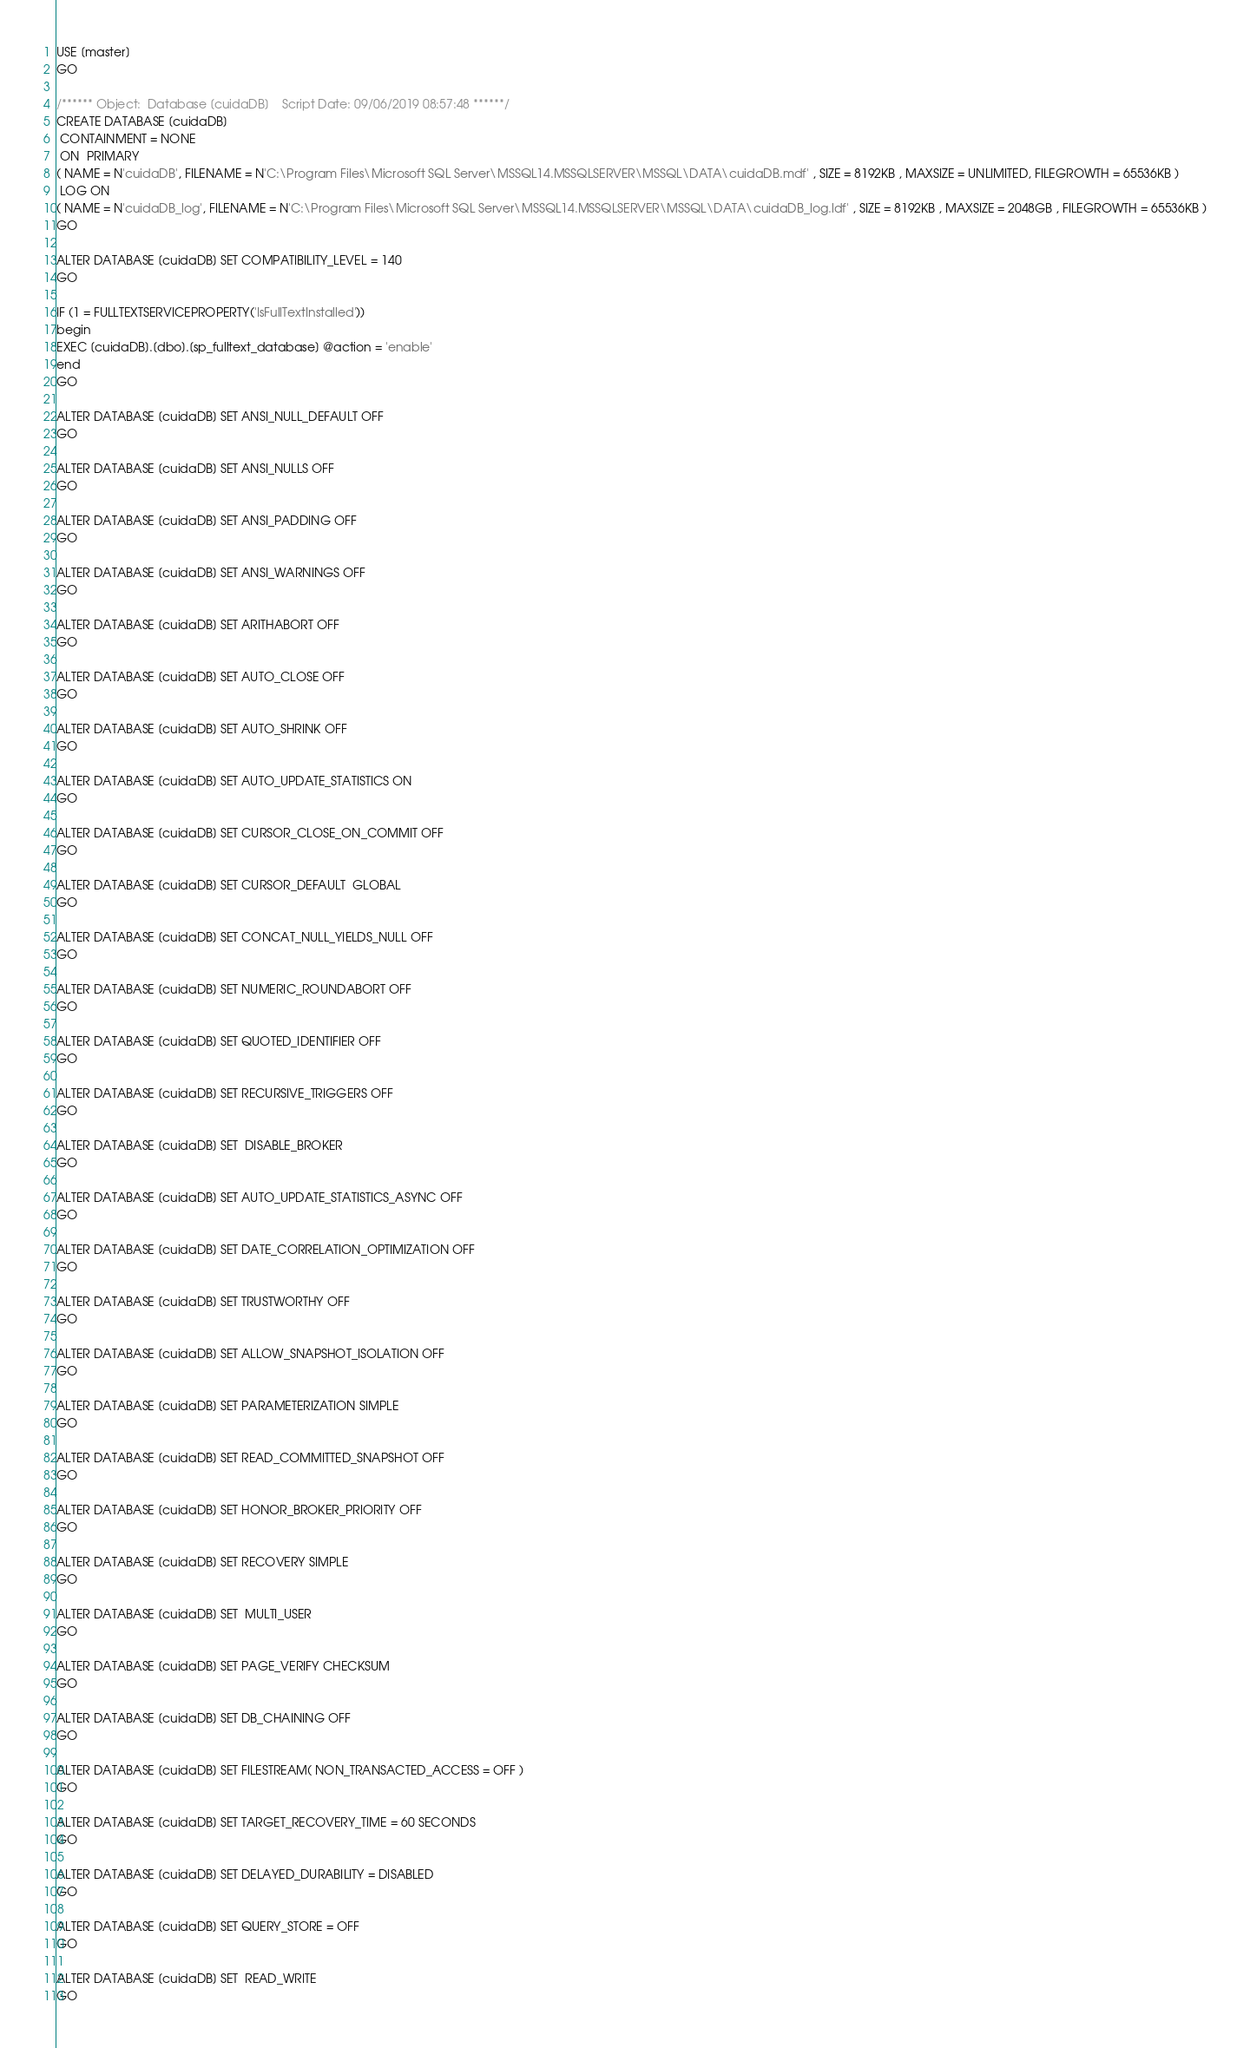Convert code to text. <code><loc_0><loc_0><loc_500><loc_500><_SQL_>USE [master]
GO

/****** Object:  Database [cuidaDB]    Script Date: 09/06/2019 08:57:48 ******/
CREATE DATABASE [cuidaDB]
 CONTAINMENT = NONE
 ON  PRIMARY 
( NAME = N'cuidaDB', FILENAME = N'C:\Program Files\Microsoft SQL Server\MSSQL14.MSSQLSERVER\MSSQL\DATA\cuidaDB.mdf' , SIZE = 8192KB , MAXSIZE = UNLIMITED, FILEGROWTH = 65536KB )
 LOG ON 
( NAME = N'cuidaDB_log', FILENAME = N'C:\Program Files\Microsoft SQL Server\MSSQL14.MSSQLSERVER\MSSQL\DATA\cuidaDB_log.ldf' , SIZE = 8192KB , MAXSIZE = 2048GB , FILEGROWTH = 65536KB )
GO

ALTER DATABASE [cuidaDB] SET COMPATIBILITY_LEVEL = 140
GO

IF (1 = FULLTEXTSERVICEPROPERTY('IsFullTextInstalled'))
begin
EXEC [cuidaDB].[dbo].[sp_fulltext_database] @action = 'enable'
end
GO

ALTER DATABASE [cuidaDB] SET ANSI_NULL_DEFAULT OFF 
GO

ALTER DATABASE [cuidaDB] SET ANSI_NULLS OFF 
GO

ALTER DATABASE [cuidaDB] SET ANSI_PADDING OFF 
GO

ALTER DATABASE [cuidaDB] SET ANSI_WARNINGS OFF 
GO

ALTER DATABASE [cuidaDB] SET ARITHABORT OFF 
GO

ALTER DATABASE [cuidaDB] SET AUTO_CLOSE OFF 
GO

ALTER DATABASE [cuidaDB] SET AUTO_SHRINK OFF 
GO

ALTER DATABASE [cuidaDB] SET AUTO_UPDATE_STATISTICS ON 
GO

ALTER DATABASE [cuidaDB] SET CURSOR_CLOSE_ON_COMMIT OFF 
GO

ALTER DATABASE [cuidaDB] SET CURSOR_DEFAULT  GLOBAL 
GO

ALTER DATABASE [cuidaDB] SET CONCAT_NULL_YIELDS_NULL OFF 
GO

ALTER DATABASE [cuidaDB] SET NUMERIC_ROUNDABORT OFF 
GO

ALTER DATABASE [cuidaDB] SET QUOTED_IDENTIFIER OFF 
GO

ALTER DATABASE [cuidaDB] SET RECURSIVE_TRIGGERS OFF 
GO

ALTER DATABASE [cuidaDB] SET  DISABLE_BROKER 
GO

ALTER DATABASE [cuidaDB] SET AUTO_UPDATE_STATISTICS_ASYNC OFF 
GO

ALTER DATABASE [cuidaDB] SET DATE_CORRELATION_OPTIMIZATION OFF 
GO

ALTER DATABASE [cuidaDB] SET TRUSTWORTHY OFF 
GO

ALTER DATABASE [cuidaDB] SET ALLOW_SNAPSHOT_ISOLATION OFF 
GO

ALTER DATABASE [cuidaDB] SET PARAMETERIZATION SIMPLE 
GO

ALTER DATABASE [cuidaDB] SET READ_COMMITTED_SNAPSHOT OFF 
GO

ALTER DATABASE [cuidaDB] SET HONOR_BROKER_PRIORITY OFF 
GO

ALTER DATABASE [cuidaDB] SET RECOVERY SIMPLE 
GO

ALTER DATABASE [cuidaDB] SET  MULTI_USER 
GO

ALTER DATABASE [cuidaDB] SET PAGE_VERIFY CHECKSUM  
GO

ALTER DATABASE [cuidaDB] SET DB_CHAINING OFF 
GO

ALTER DATABASE [cuidaDB] SET FILESTREAM( NON_TRANSACTED_ACCESS = OFF ) 
GO

ALTER DATABASE [cuidaDB] SET TARGET_RECOVERY_TIME = 60 SECONDS 
GO

ALTER DATABASE [cuidaDB] SET DELAYED_DURABILITY = DISABLED 
GO

ALTER DATABASE [cuidaDB] SET QUERY_STORE = OFF
GO

ALTER DATABASE [cuidaDB] SET  READ_WRITE 
GO


</code> 